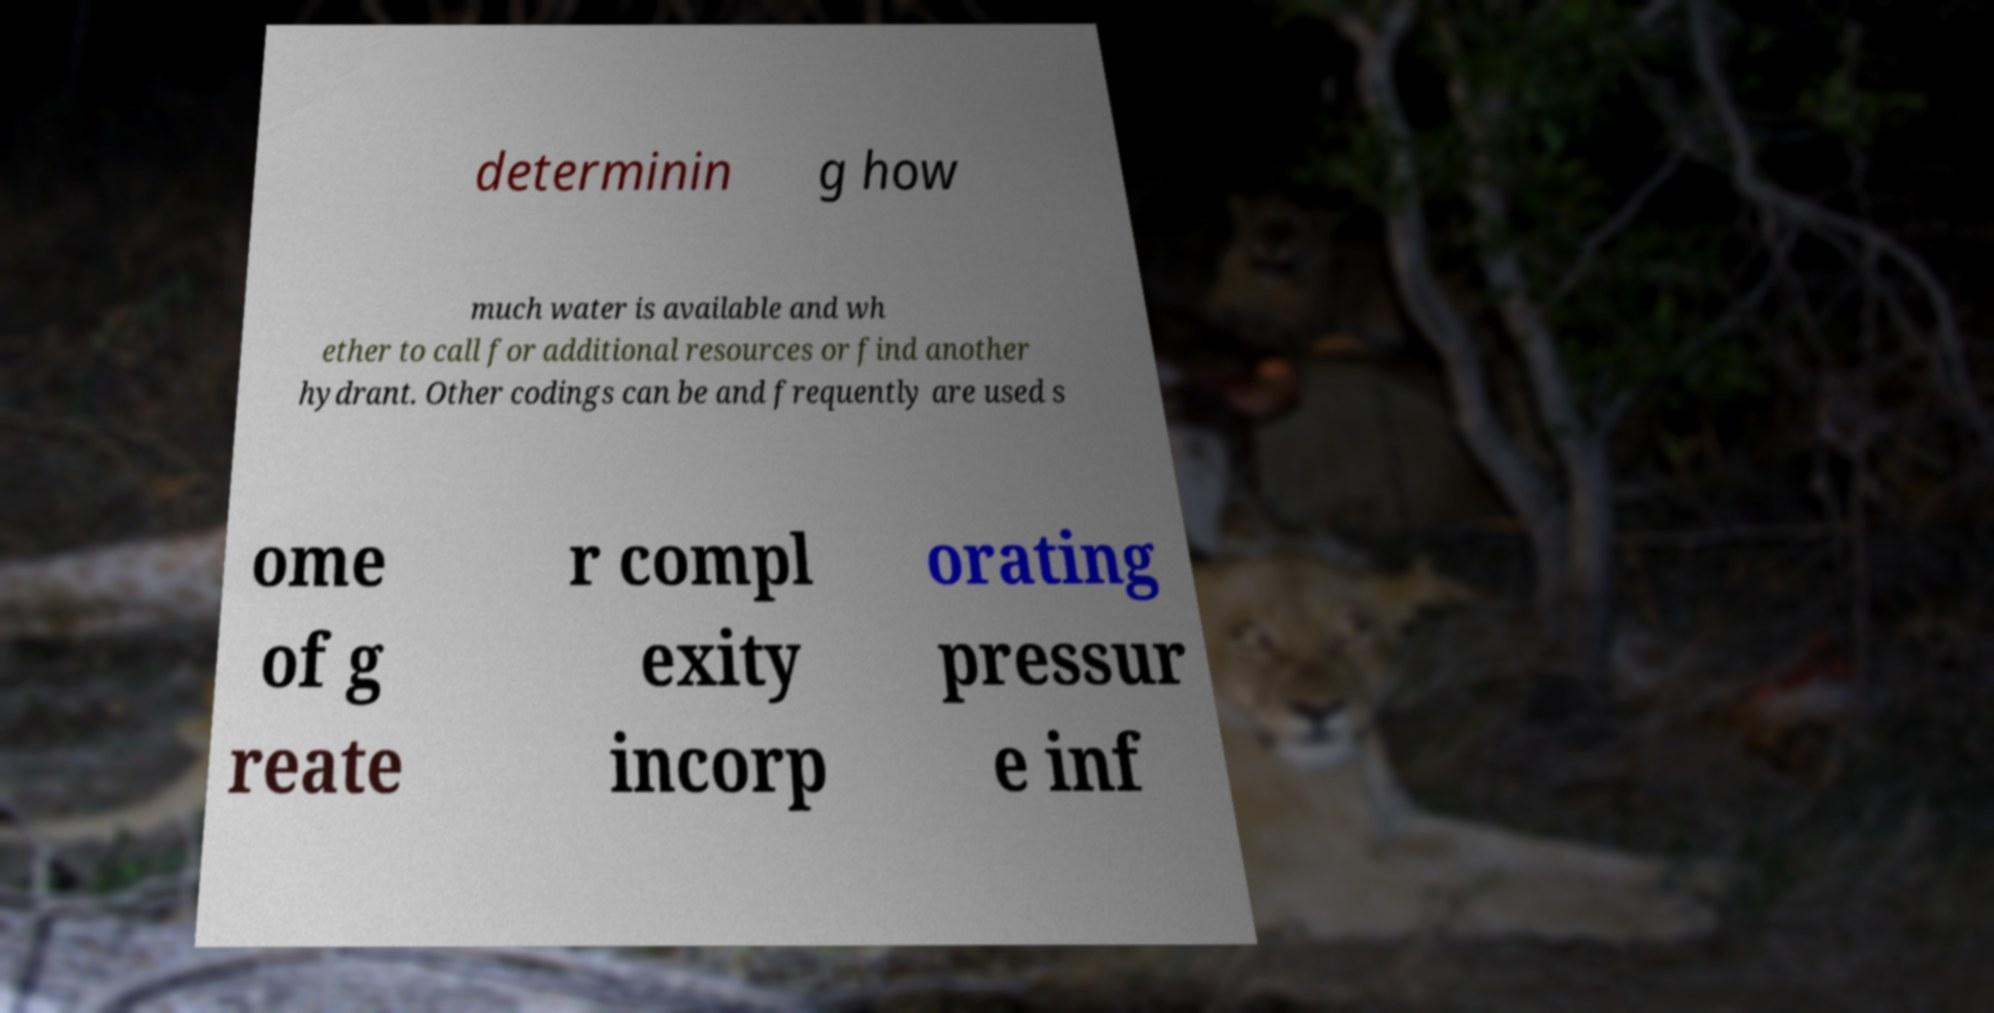Could you extract and type out the text from this image? determinin g how much water is available and wh ether to call for additional resources or find another hydrant. Other codings can be and frequently are used s ome of g reate r compl exity incorp orating pressur e inf 